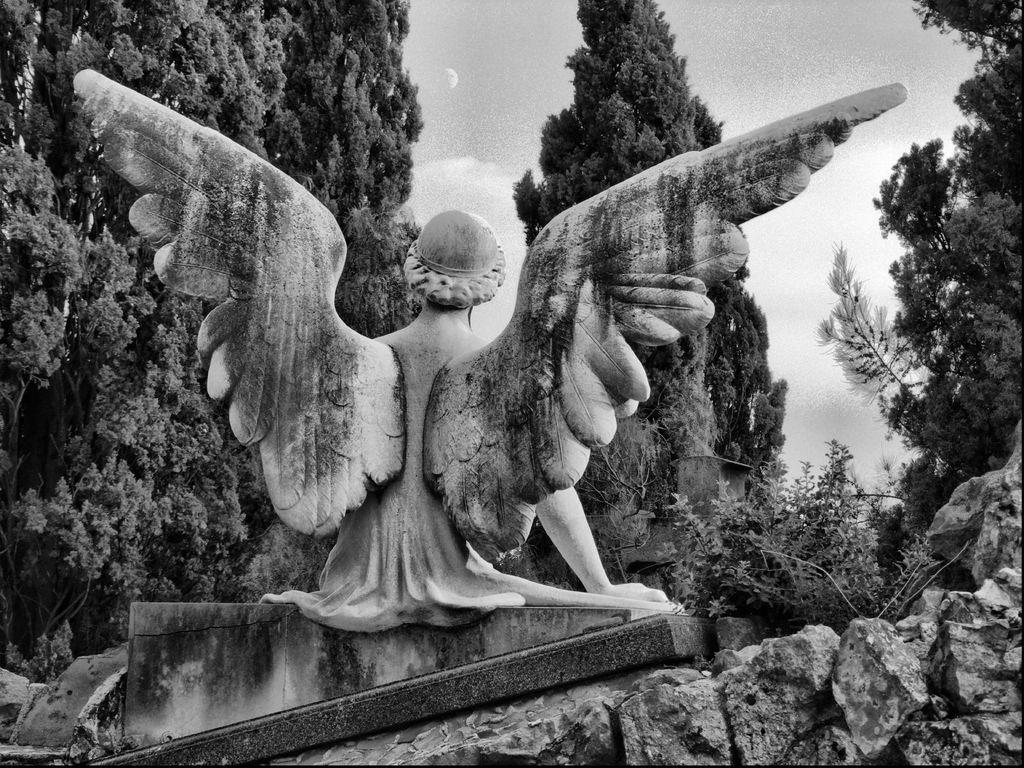What is the main subject in the middle of the image? There is a statue in the middle of the image. What can be seen in the background of the image? There are trees in the background of the image. What is visible at the top of the image? The sky is visible at the top of the image. What type of joke is being told by the statue in the image? There is no joke being told by the statue in the image; it is a stationary object. 